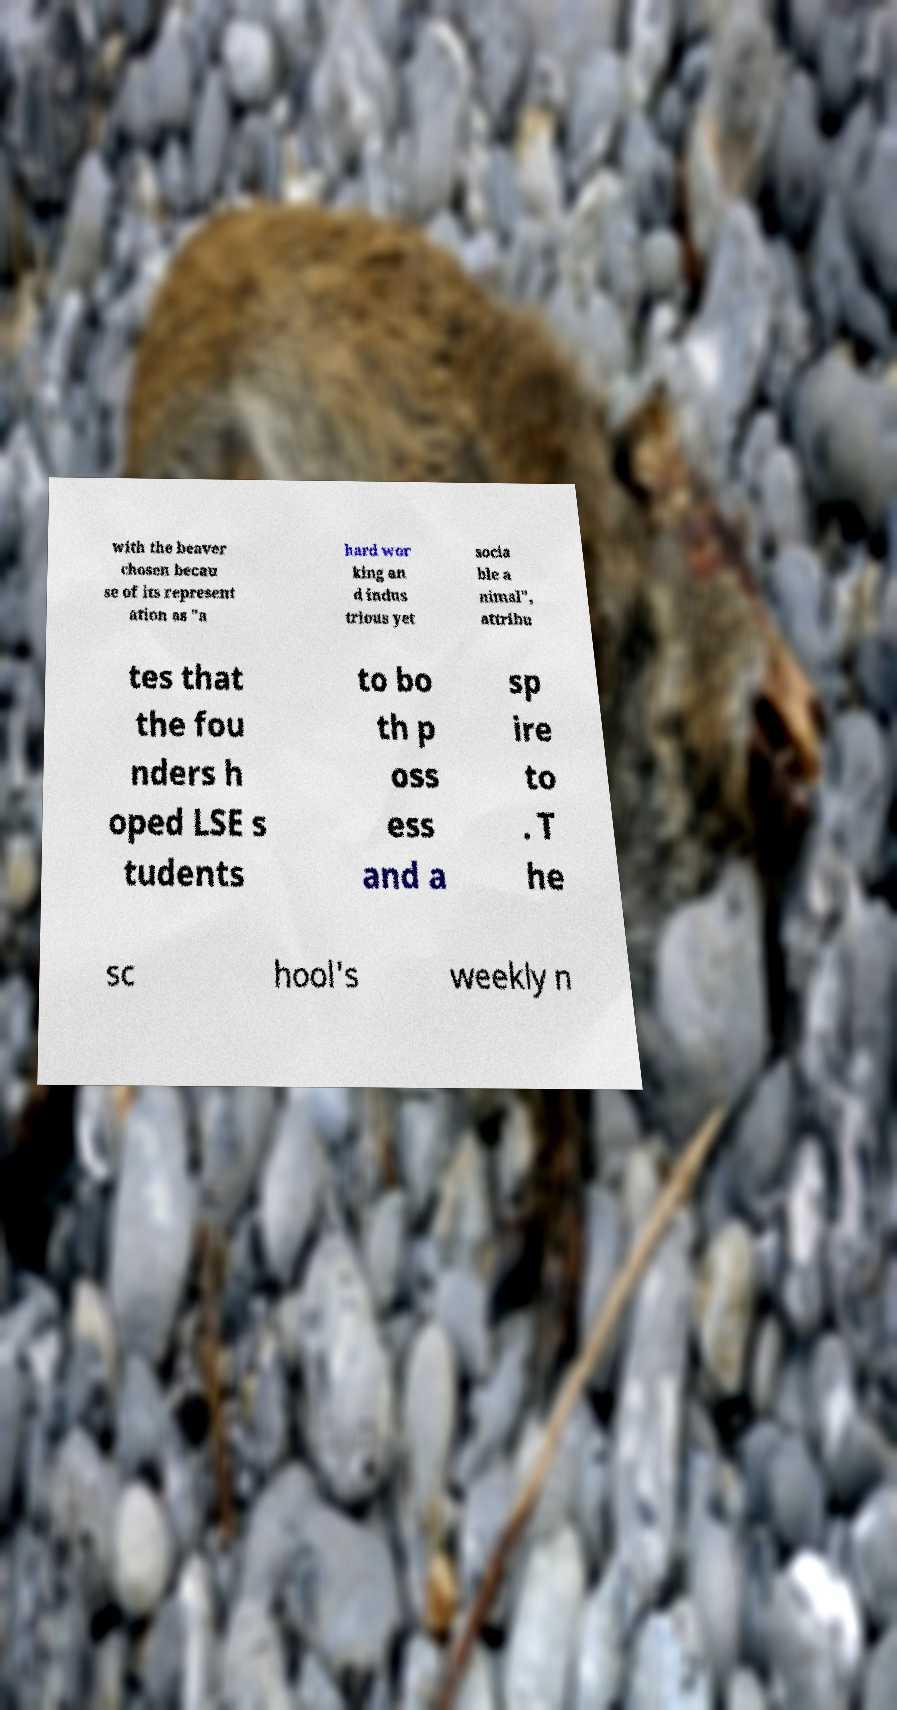Can you read and provide the text displayed in the image?This photo seems to have some interesting text. Can you extract and type it out for me? with the beaver chosen becau se of its represent ation as "a hard wor king an d indus trious yet socia ble a nimal", attribu tes that the fou nders h oped LSE s tudents to bo th p oss ess and a sp ire to . T he sc hool's weekly n 